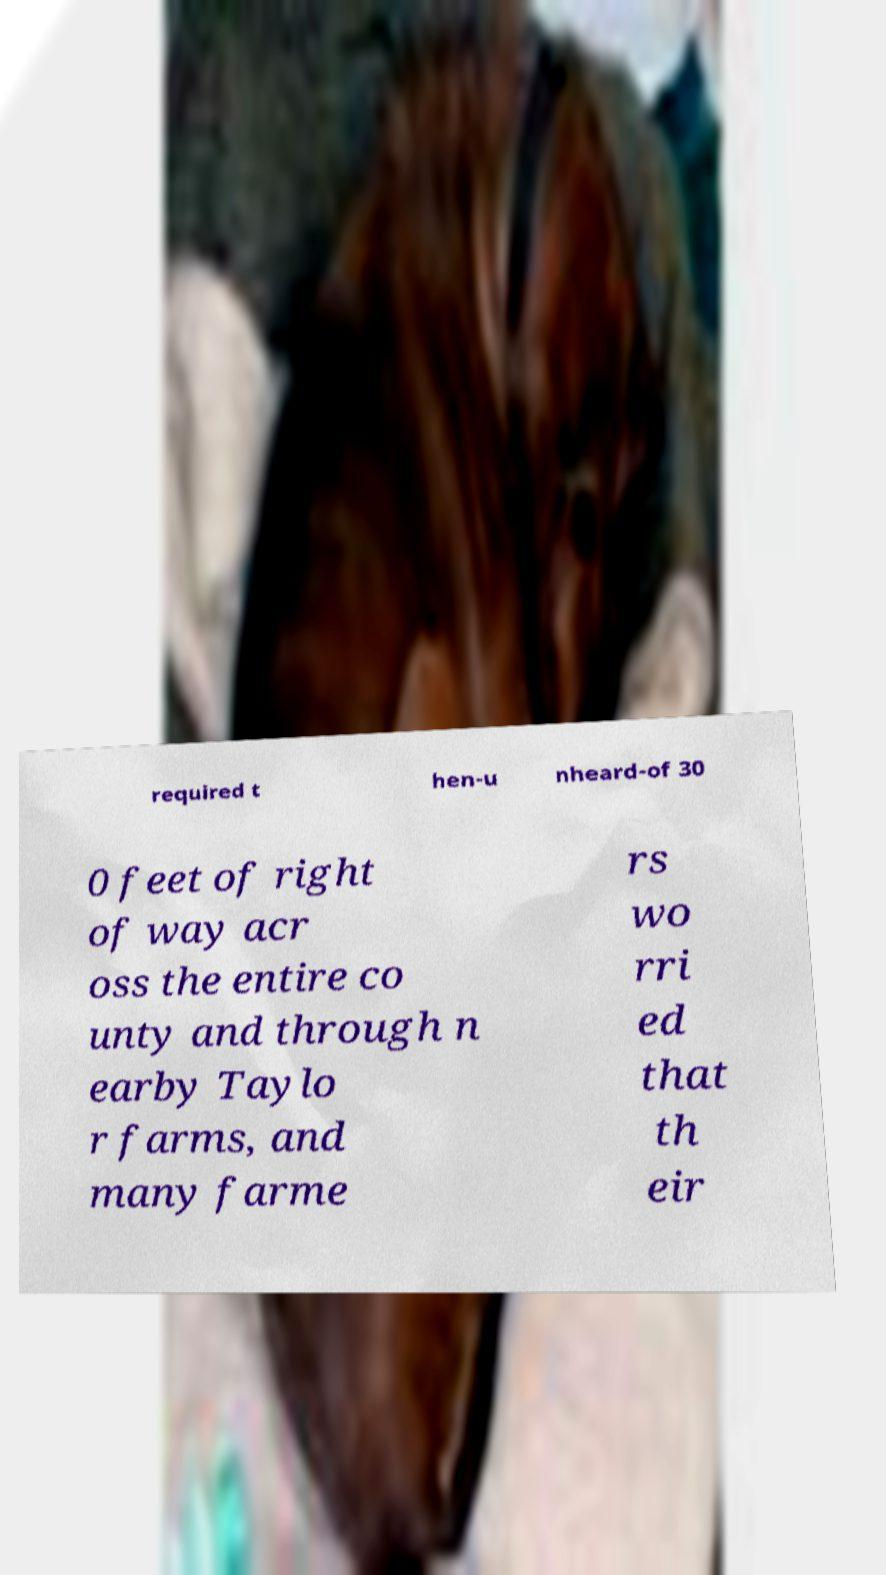Could you assist in decoding the text presented in this image and type it out clearly? required t hen-u nheard-of 30 0 feet of right of way acr oss the entire co unty and through n earby Taylo r farms, and many farme rs wo rri ed that th eir 